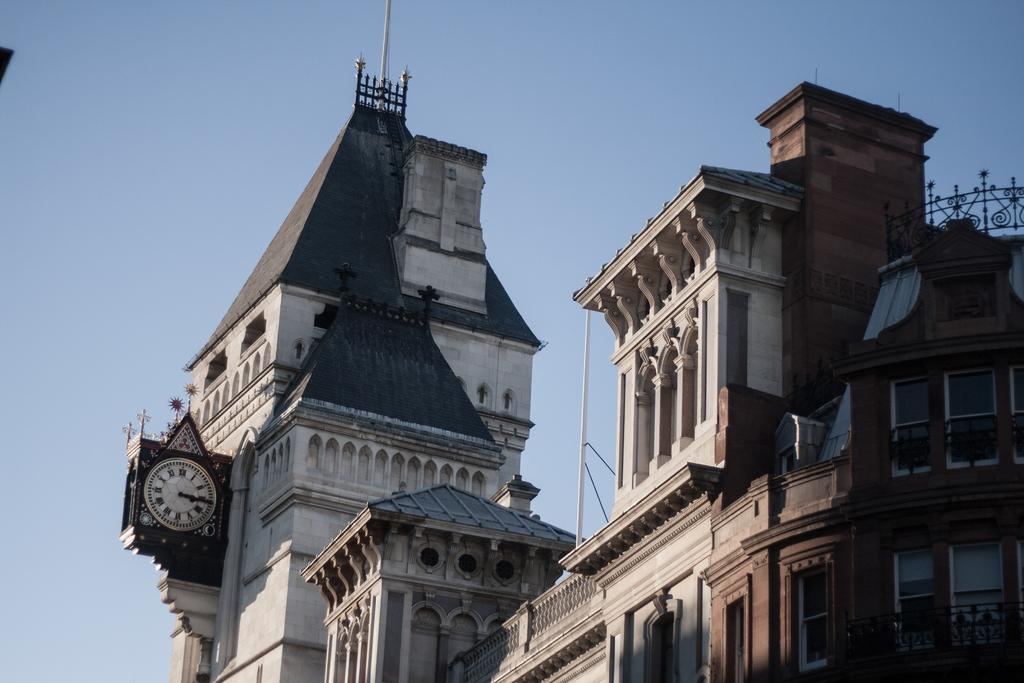What type of structures can be seen in the image? There are buildings in the image. Can you describe a specific object on one of the buildings? There is a clock on a wall in the image. What can be seen in the background of the image? The sky is visible in the background of the image. What type of treatment is being discussed by the committee in the image? There is no committee or discussion of treatment present in the image; it features buildings and a clock on a wall. 